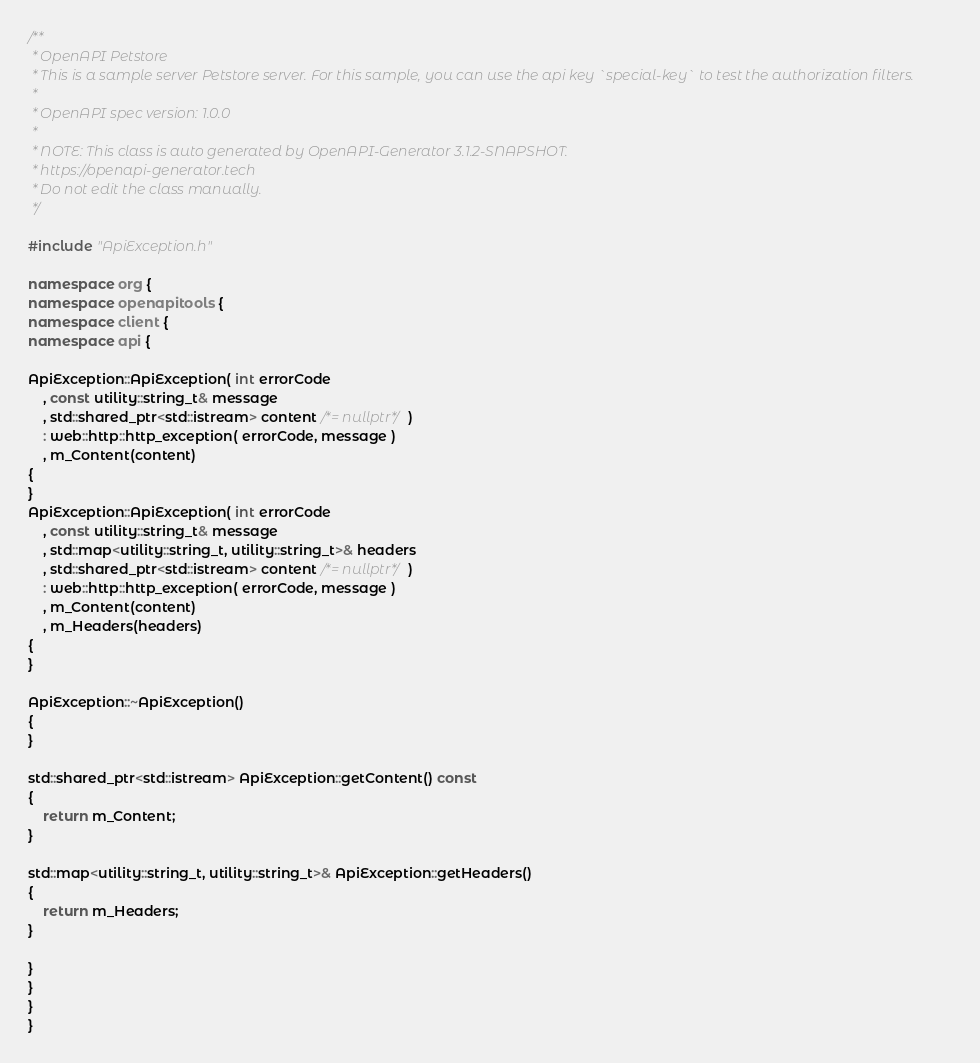Convert code to text. <code><loc_0><loc_0><loc_500><loc_500><_C++_>/**
 * OpenAPI Petstore
 * This is a sample server Petstore server. For this sample, you can use the api key `special-key` to test the authorization filters.
 *
 * OpenAPI spec version: 1.0.0
 *
 * NOTE: This class is auto generated by OpenAPI-Generator 3.1.2-SNAPSHOT.
 * https://openapi-generator.tech
 * Do not edit the class manually.
 */

#include "ApiException.h"

namespace org {
namespace openapitools {
namespace client {
namespace api {

ApiException::ApiException( int errorCode
    , const utility::string_t& message
    , std::shared_ptr<std::istream> content /*= nullptr*/ )
    : web::http::http_exception( errorCode, message )
    , m_Content(content)
{
}
ApiException::ApiException( int errorCode
    , const utility::string_t& message
    , std::map<utility::string_t, utility::string_t>& headers
    , std::shared_ptr<std::istream> content /*= nullptr*/ )
    : web::http::http_exception( errorCode, message )
    , m_Content(content)
    , m_Headers(headers)
{
}

ApiException::~ApiException()
{
}

std::shared_ptr<std::istream> ApiException::getContent() const
{
    return m_Content;
}

std::map<utility::string_t, utility::string_t>& ApiException::getHeaders()
{
    return m_Headers;
}

}
}
}
}
</code> 